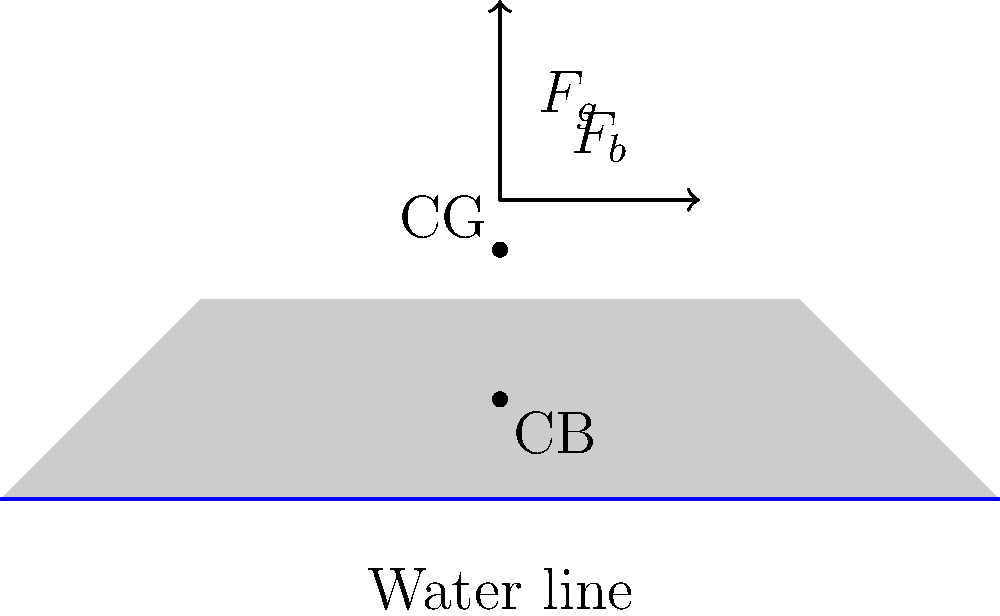As a small boat rental shop owner in Keuruu, Finland, you need to ensure the safety of your customers. Consider a small boat with a length of 4 meters and a width of 1.5 meters. The boat's weight is 150 kg, and its center of gravity (CG) is 0.5 meters above the water line when empty. The water density is 1000 kg/m³. Using the free body diagram provided, calculate the maximum safe load capacity of the boat if the safety factor is 1.5 and the maximum allowable draft is 0.3 meters. To calculate the maximum safe load capacity, we'll follow these steps:

1. Calculate the boat's volume displacement at maximum draft:
   $V = L \times W \times D_{max} = 4 \text{ m} \times 1.5 \text{ m} \times 0.3 \text{ m} = 1.8 \text{ m}^3$

2. Calculate the maximum buoyant force:
   $F_b = \rho \times g \times V = 1000 \text{ kg/m}^3 \times 9.81 \text{ m/s}^2 \times 1.8 \text{ m}^3 = 17,658 \text{ N}$

3. Calculate the gravitational force of the empty boat:
   $F_g(\text{boat}) = m \times g = 150 \text{ kg} \times 9.81 \text{ m/s}^2 = 1,471.5 \text{ N}$

4. Calculate the maximum additional load force:
   $F_g(\text{load}) = F_b - F_g(\text{boat}) = 17,658 \text{ N} - 1,471.5 \text{ N} = 16,186.5 \text{ N}$

5. Apply the safety factor:
   $F_g(\text{safe load}) = F_g(\text{load}) \div 1.5 = 16,186.5 \text{ N} \div 1.5 = 10,791 \text{ N}$

6. Convert the force to mass:
   $m_{\text{safe load}} = F_g(\text{safe load}) \div g = 10,791 \text{ N} \div 9.81 \text{ m/s}^2 \approx 1,100 \text{ kg}$

Therefore, the maximum safe load capacity of the boat is approximately 1,100 kg.
Answer: 1,100 kg 